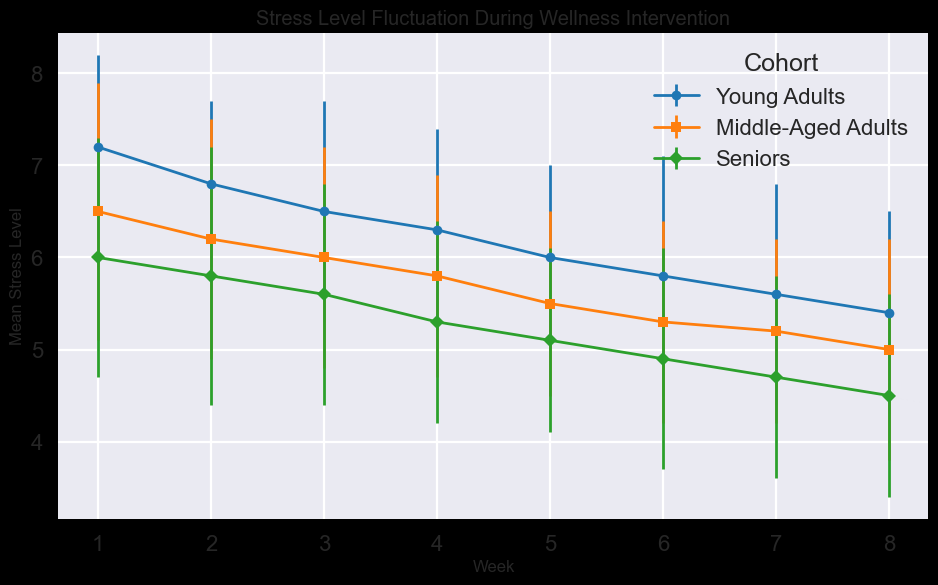What is the overall trend in stress levels for the Young Adults cohort over the 8 weeks? The Young Adults cohort shows a decreasing trend in stress levels over the 8 weeks. From week 1 to week 8, the mean stress level decreases from 7.2 to 5.4.
Answer: Decreasing Which cohort shows the lowest mean stress level at the end of the intervention? By examining the mean stress levels in week 8, the Seniors cohort has the lowest mean stress level of 4.5 compared to 5.0 for Middle-Aged Adults and 5.4 for Young Adults.
Answer: Seniors What is the average mean stress level for Middle-Aged Adults over the 8 weeks? The mean stress levels for Middle-Aged Adults are: 6.5, 6.2, 6.0, 5.8, 5.5, 5.3, 5.2, and 5.0. To find the average, sum these values and divide by 8: (6.5 + 6.2 + 6.0 + 5.8 + 5.5 + 5.3 + 5.2 + 5.0) / 8 = 5.69.
Answer: 5.69 Between which weeks did the Young Adults cohort experience the greatest decrease in mean stress level? By examining the changes in mean stress levels week by week for Young Adults: Week 1-2: 0.4, Week 2-3: 0.3, Week 3-4: 0.2, Week 4-5: 0.3, Week 5-6: 0.2, Week 6-7: 0.2, Week 7-8: 0.2. The greatest decrease is between Week 1 and Week 2.
Answer: Week 1 to Week 2 Which cohort has the highest variability in stress levels during the intervention, as indicated by the standard deviations? Observing the standard deviations across cohorts, the Middle-Aged Adults cohort has the highest standard deviations in most weeks, indicating higher variability.
Answer: Middle-Aged Adults Did any cohort show an increase in stress level during the intervention? All cohorts show a consistent decrease in mean stress levels over the 8 weeks. No cohort shows an increase during the intervention.
Answer: No Which weeks show overlapping mean stress levels with standard deviations for all three cohorts? By checking the error bars, Weeks 4 and 5 show overlapping mean stress levels with standard deviations for all three cohorts.
Answer: Weeks 4 and 5 How much did the mean stress level decrease for the Seniors cohort from the beginning to the end of the intervention? The mean stress level for the Seniors cohort decreased from 6.0 in Week 1 to 4.5 in Week 8, a decrease of 1.5 units.
Answer: 1.5 units In which week is the mean stress level for Middle-Aged Adults equal to the mean stress level for Young Adults? The mean stress levels for both Middle-Aged Adults and Young Adults are equal in Week 5, with both cohorts having a stress level of 5.5 for Middle-Aged Adults and 6.0 for Young Adults.
Answer: None Between which weeks did the Seniors cohort experience the smallest decrease in mean stress level? By examining the changes in the mean stress levels week by week for Seniors: Week 1-2: 0.2, Week 2-3: 0.2, Week 3-4: 0.3, Week 4-5: 0.2, Week 5-6: 0.2, Week 6-7: 0.2, Week 7-8: 0.2. The smallest decreases are Weeks 1-2, 2-3, 4-5, 5-6, 6-7, and 7-8 (all equal).
Answer: Week 1-2, 2-3, 4-5, 5-6, 6-7, and 7-8 